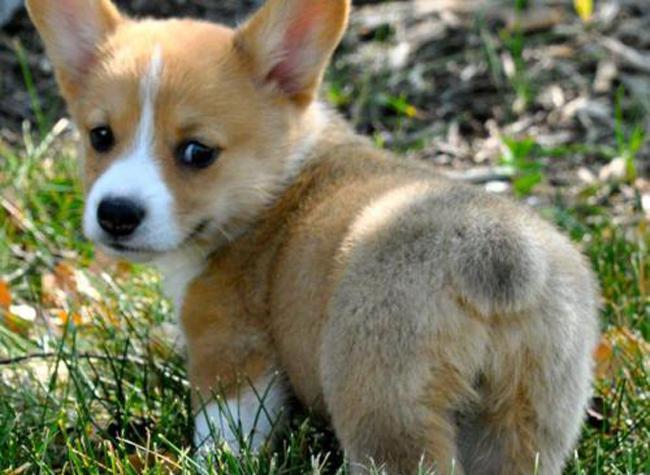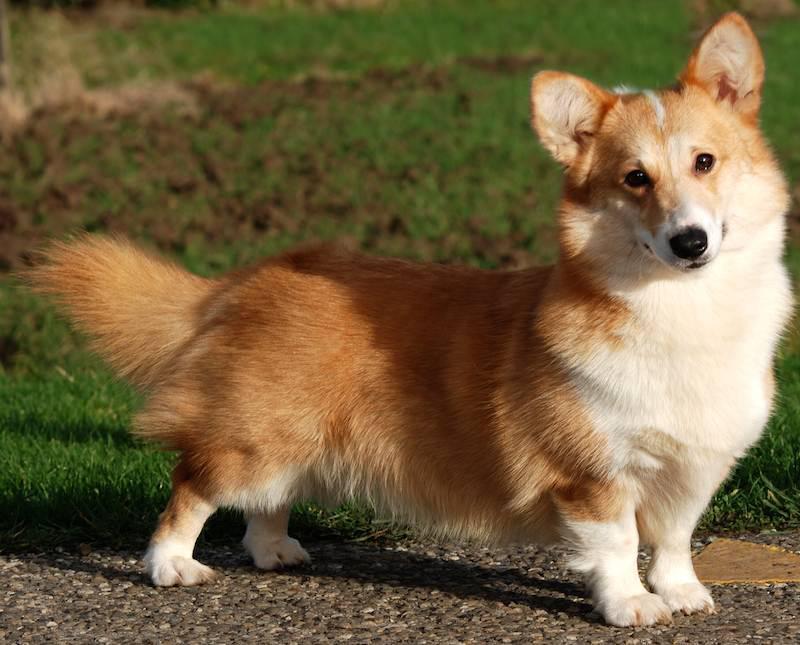The first image is the image on the left, the second image is the image on the right. For the images shown, is this caption "There are two puppies with ears pointing up as they run right together on grass." true? Answer yes or no. No. The first image is the image on the left, the second image is the image on the right. Considering the images on both sides, is "Both images in the pair include two corgis next to each other." valid? Answer yes or no. No. 